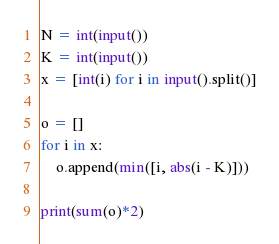<code> <loc_0><loc_0><loc_500><loc_500><_Python_>N = int(input())
K = int(input())
x = [int(i) for i in input().split()]

o = []
for i in x:
    o.append(min([i, abs(i - K)]))

print(sum(o)*2)</code> 